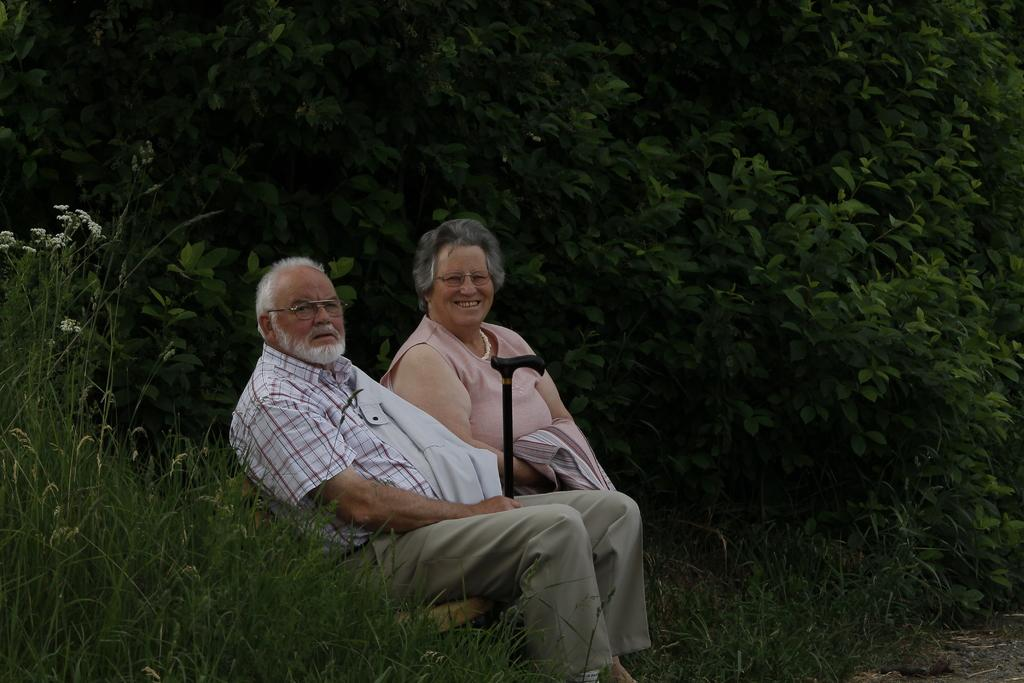Who is in the image? There is an old couple in the image. What are the old couple doing in the image? The old couple is sitting on a bench. Where is the bench located? The bench is on a grassland. What can be seen around the grassland? The grassland is surrounded by plants. What type of mint is growing on the old couple's heads in the image? There is no mint or any other plants growing on the old couple's heads in the image. 